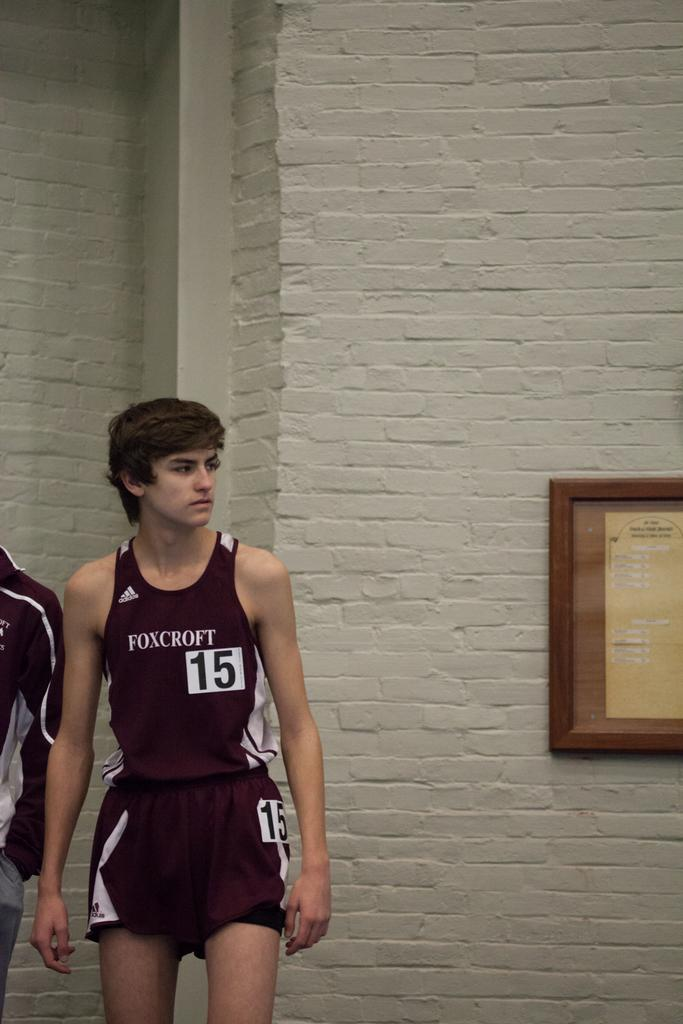<image>
Summarize the visual content of the image. A boy wearing jersey number 15 for Foxcroft stands near a brick wall 